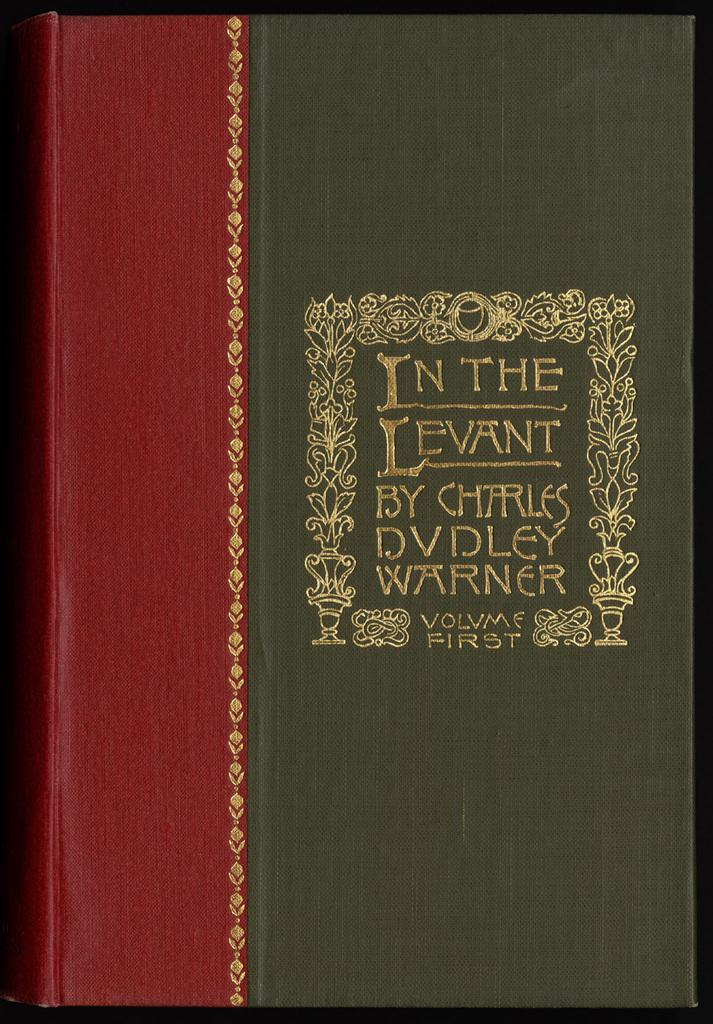<image>
Offer a succinct explanation of the picture presented. In the Levant by Charles DVDLey Warner that is the first volume of books. 